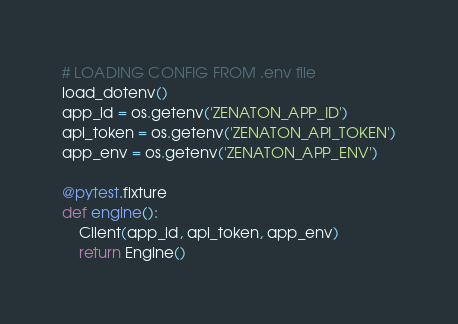Convert code to text. <code><loc_0><loc_0><loc_500><loc_500><_Python_>
# LOADING CONFIG FROM .env file
load_dotenv()
app_id = os.getenv('ZENATON_APP_ID')
api_token = os.getenv('ZENATON_API_TOKEN')
app_env = os.getenv('ZENATON_APP_ENV')

@pytest.fixture
def engine():
    Client(app_id, api_token, app_env)
    return Engine()
</code> 